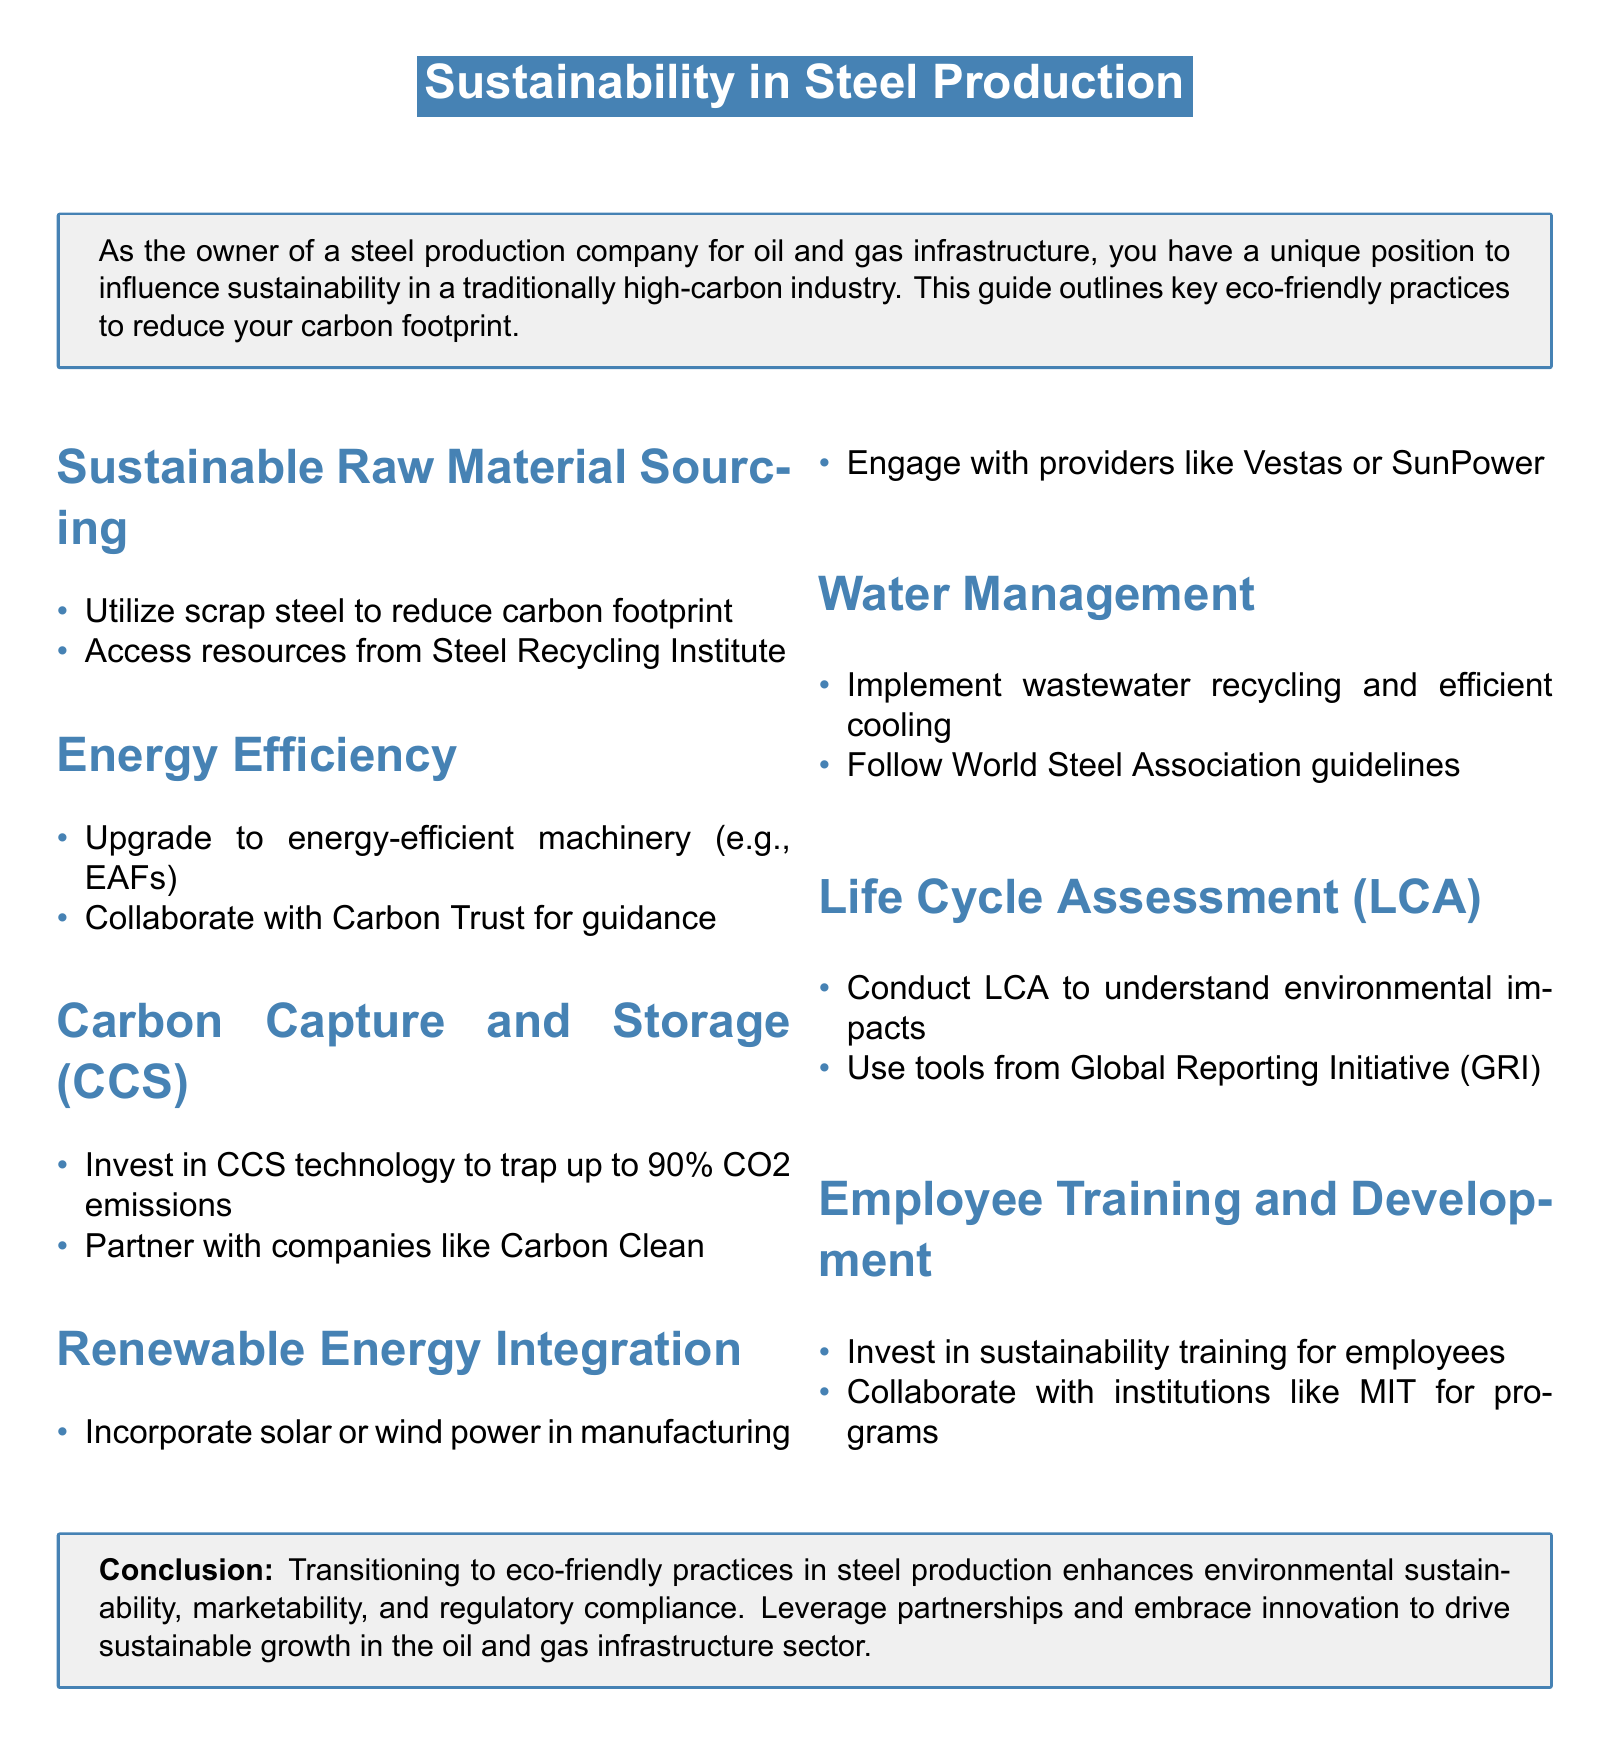What is the title of the document? The title of the document is highlighted at the beginning, which summarizes the subject matter addressed.
Answer: Sustainability in Steel Production How much CO2 emissions can CCS technology trap? The document mentions a specific percentage of CO2 emissions that can be trapped using CCS technology.
Answer: 90% Which organization provides resources for scrap steel? The document lists an organization that specializes in recycling and provides materials to reduce carbon footprint.
Answer: Steel Recycling Institute What type of energy-efficient machinery should be upgraded? The guide suggests upgrading a specific type of machinery that is commonly used in steel production for better energy efficiency.
Answer: EAFs What type of training should employees receive? The document indicates the type of training aimed at enhancing sustainability knowledge among employees.
Answer: Sustainability training Which renewable energy providers are mentioned? The document cites specific companies that provide renewable energy solutions for incorporation in manufacturing.
Answer: Vestas or SunPower What guidelines should be followed for water management? The document advises adherence to certain guidelines for effective water management practices in the steel production process.
Answer: World Steel Association What tool can be used for conducting Life Cycle Assessment? The guide provides a tool recommended for assessing the environmental impacts of production activities.
Answer: Global Reporting Initiative (GRI) 